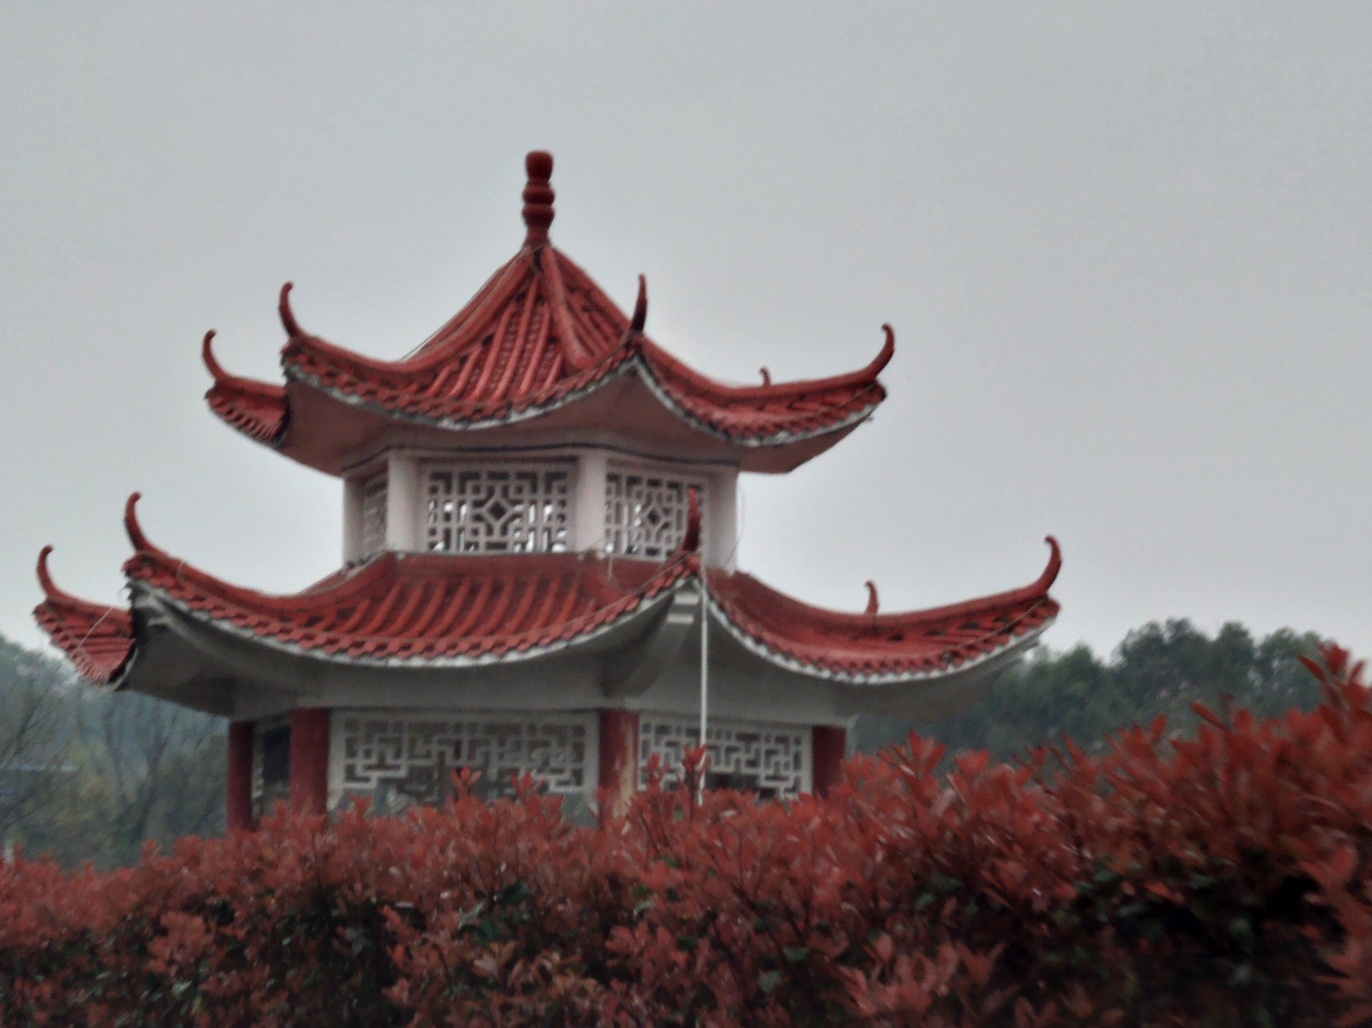Can you describe the architectural style of the building in this image? The building appears to showcase traditional East Asian architectural elements, such as the upturned eaves and intricate latticework commonly found in classical Chinese construction. 